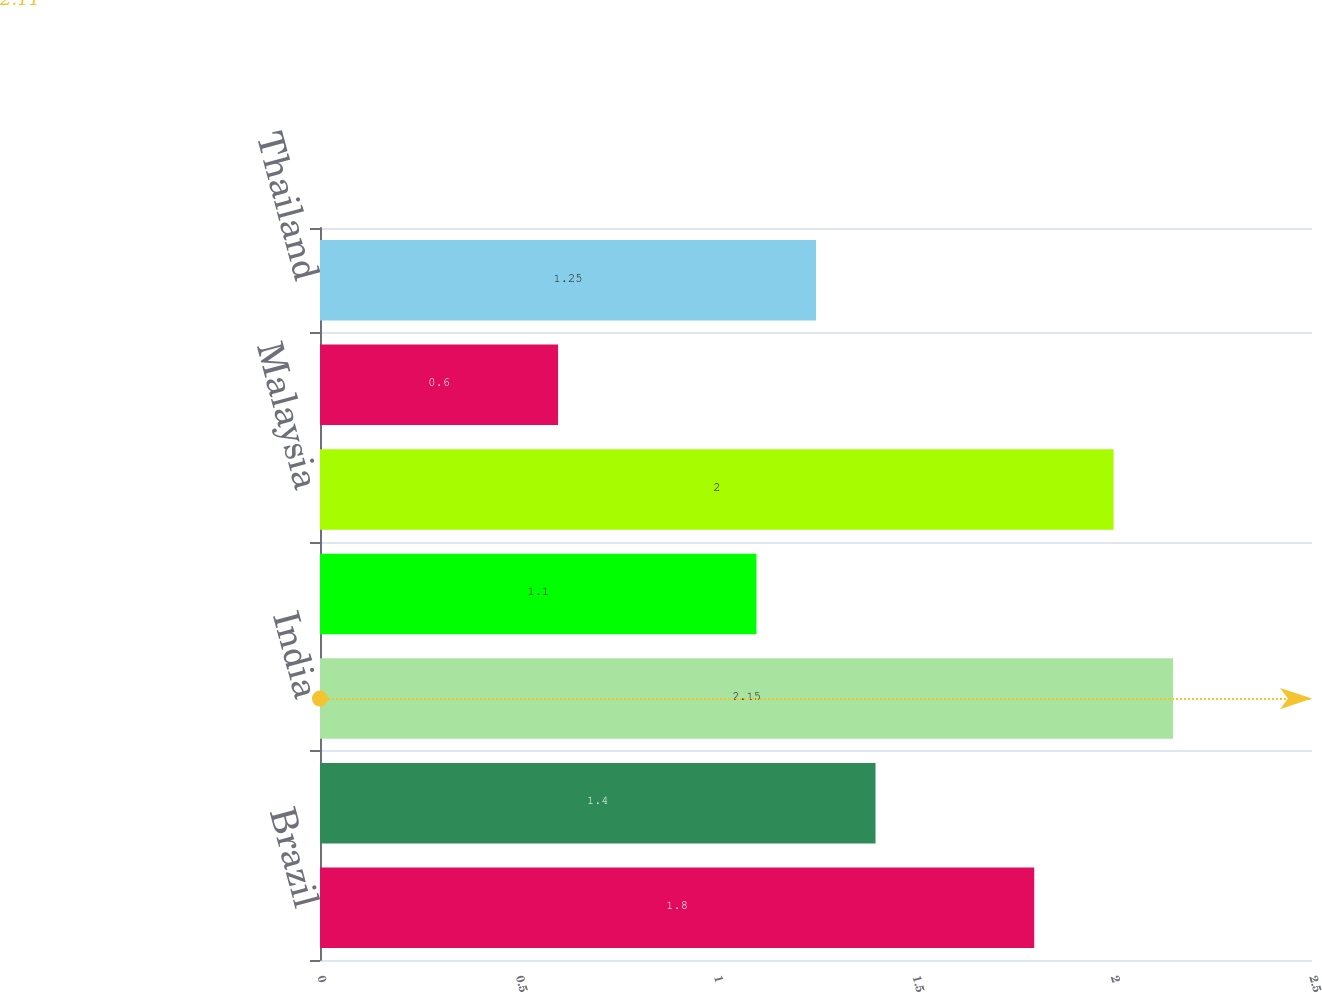Convert chart to OTSL. <chart><loc_0><loc_0><loc_500><loc_500><bar_chart><fcel>Brazil<fcel>South Korea<fcel>India<fcel>China<fcel>Malaysia<fcel>Taiwan<fcel>Thailand<nl><fcel>1.8<fcel>1.4<fcel>2.15<fcel>1.1<fcel>2<fcel>0.6<fcel>1.25<nl></chart> 